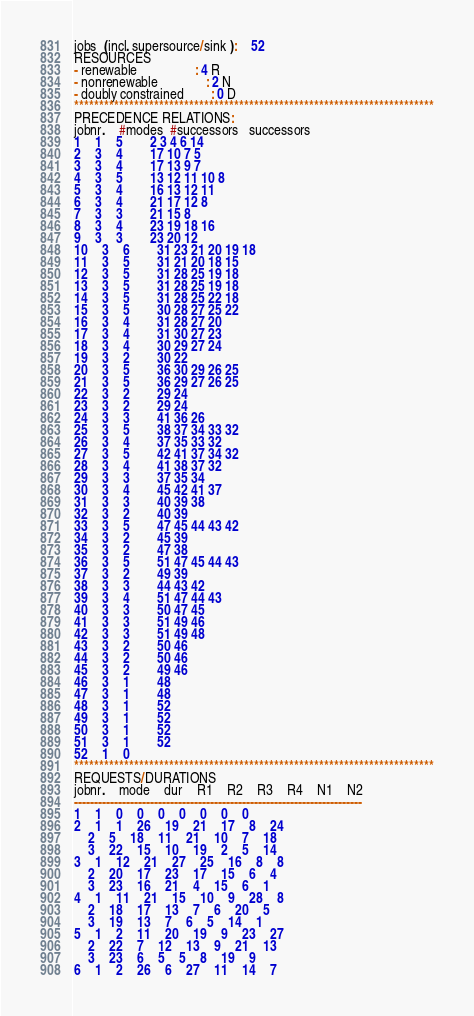<code> <loc_0><loc_0><loc_500><loc_500><_ObjectiveC_>jobs  (incl. supersource/sink ):	52
RESOURCES
- renewable                 : 4 R
- nonrenewable              : 2 N
- doubly constrained        : 0 D
************************************************************************
PRECEDENCE RELATIONS:
jobnr.    #modes  #successors   successors
1	1	5		2 3 4 6 14 
2	3	4		17 10 7 5 
3	3	4		17 13 9 7 
4	3	5		13 12 11 10 8 
5	3	4		16 13 12 11 
6	3	4		21 17 12 8 
7	3	3		21 15 8 
8	3	4		23 19 18 16 
9	3	3		23 20 12 
10	3	6		31 23 21 20 19 18 
11	3	5		31 21 20 18 15 
12	3	5		31 28 25 19 18 
13	3	5		31 28 25 19 18 
14	3	5		31 28 25 22 18 
15	3	5		30 28 27 25 22 
16	3	4		31 28 27 20 
17	3	4		31 30 27 23 
18	3	4		30 29 27 24 
19	3	2		30 22 
20	3	5		36 30 29 26 25 
21	3	5		36 29 27 26 25 
22	3	2		29 24 
23	3	2		29 24 
24	3	3		41 36 26 
25	3	5		38 37 34 33 32 
26	3	4		37 35 33 32 
27	3	5		42 41 37 34 32 
28	3	4		41 38 37 32 
29	3	3		37 35 34 
30	3	4		45 42 41 37 
31	3	3		40 39 38 
32	3	2		40 39 
33	3	5		47 45 44 43 42 
34	3	2		45 39 
35	3	2		47 38 
36	3	5		51 47 45 44 43 
37	3	2		49 39 
38	3	3		44 43 42 
39	3	4		51 47 44 43 
40	3	3		50 47 45 
41	3	3		51 49 46 
42	3	3		51 49 48 
43	3	2		50 46 
44	3	2		50 46 
45	3	2		49 46 
46	3	1		48 
47	3	1		48 
48	3	1		52 
49	3	1		52 
50	3	1		52 
51	3	1		52 
52	1	0		
************************************************************************
REQUESTS/DURATIONS
jobnr.	mode	dur	R1	R2	R3	R4	N1	N2	
------------------------------------------------------------------------
1	1	0	0	0	0	0	0	0	
2	1	1	26	19	21	17	8	24	
	2	5	18	11	21	10	7	18	
	3	22	15	10	19	2	5	14	
3	1	12	21	27	25	16	8	8	
	2	20	17	23	17	15	6	4	
	3	23	16	21	4	15	6	1	
4	1	11	21	15	10	9	28	8	
	2	18	17	13	7	6	20	5	
	3	19	13	7	6	5	14	1	
5	1	2	11	20	19	9	23	27	
	2	22	7	12	13	9	21	13	
	3	23	6	5	5	8	19	9	
6	1	2	26	6	27	11	14	7	</code> 